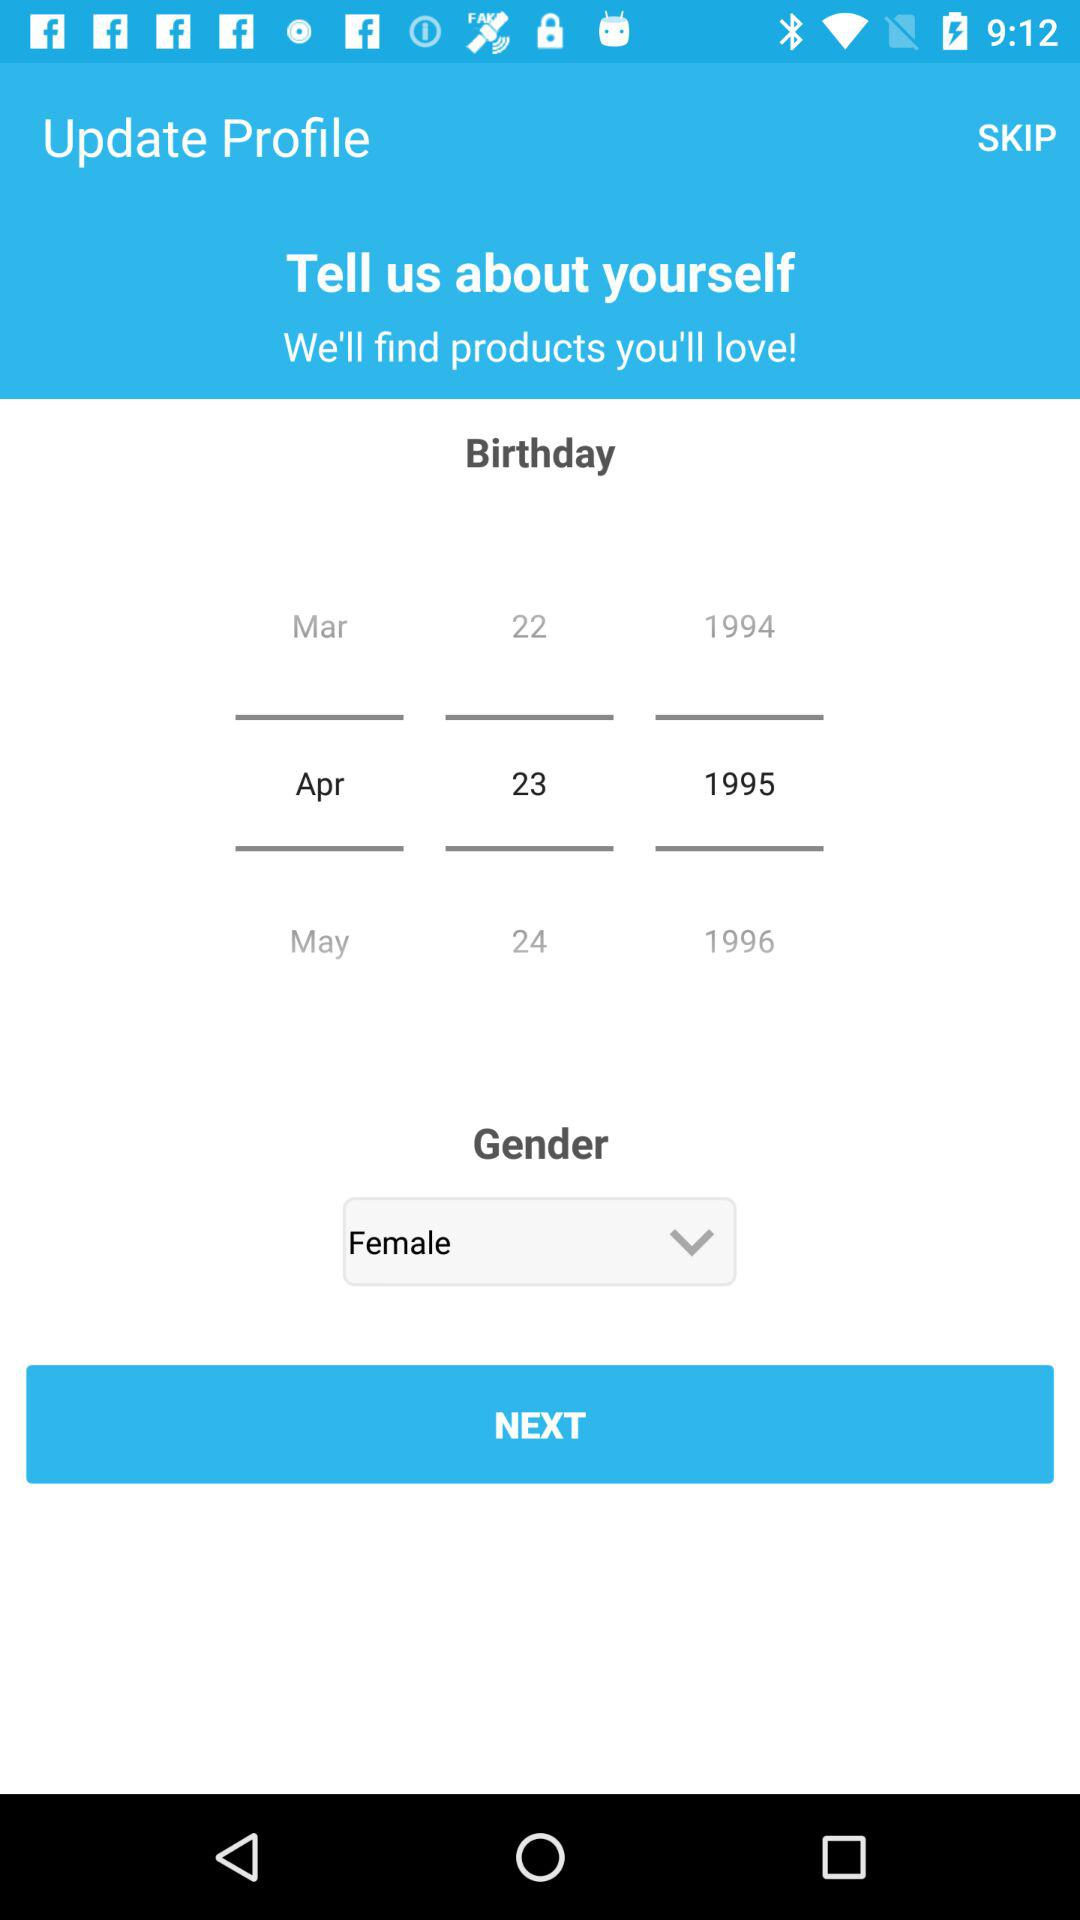What is the selected birthday date? The selected birthday date is April 23, 1995. 